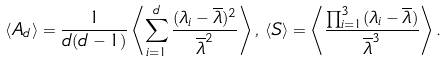Convert formula to latex. <formula><loc_0><loc_0><loc_500><loc_500>\langle { A _ { d } } \rangle = \frac { 1 } { d ( d - 1 ) } \left \langle \sum _ { i = 1 } ^ { d } \frac { ( \lambda _ { i } - { \overline { \lambda } } ) ^ { 2 } } { \overline { \lambda } ^ { 2 } } \right \rangle , \, \langle { S } \rangle = \left \langle \frac { \prod _ { i = 1 } ^ { 3 } ( \lambda _ { i } - { \overline { \lambda } } ) } { { \overline { \lambda } } ^ { 3 } } \right \rangle .</formula> 